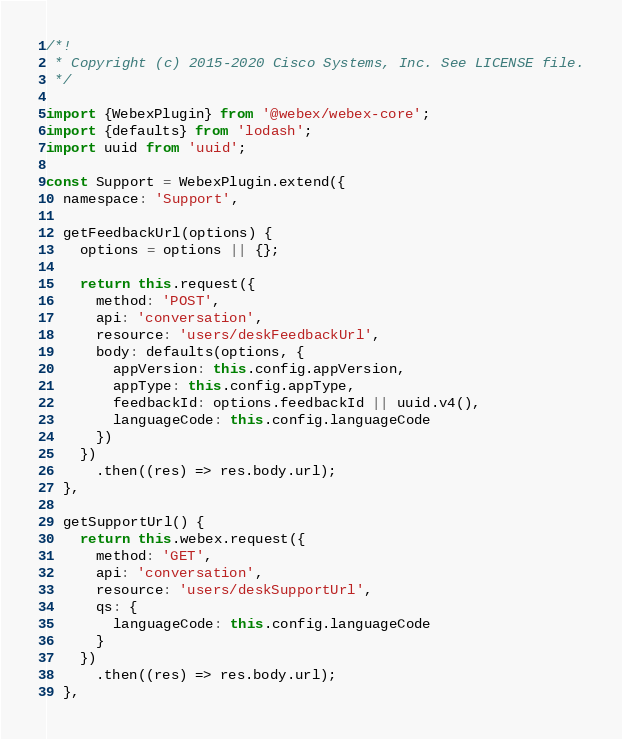Convert code to text. <code><loc_0><loc_0><loc_500><loc_500><_JavaScript_>/*!
 * Copyright (c) 2015-2020 Cisco Systems, Inc. See LICENSE file.
 */

import {WebexPlugin} from '@webex/webex-core';
import {defaults} from 'lodash';
import uuid from 'uuid';

const Support = WebexPlugin.extend({
  namespace: 'Support',

  getFeedbackUrl(options) {
    options = options || {};

    return this.request({
      method: 'POST',
      api: 'conversation',
      resource: 'users/deskFeedbackUrl',
      body: defaults(options, {
        appVersion: this.config.appVersion,
        appType: this.config.appType,
        feedbackId: options.feedbackId || uuid.v4(),
        languageCode: this.config.languageCode
      })
    })
      .then((res) => res.body.url);
  },

  getSupportUrl() {
    return this.webex.request({
      method: 'GET',
      api: 'conversation',
      resource: 'users/deskSupportUrl',
      qs: {
        languageCode: this.config.languageCode
      }
    })
      .then((res) => res.body.url);
  },
</code> 